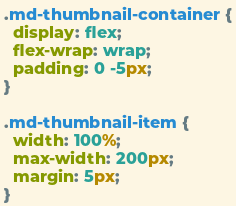<code> <loc_0><loc_0><loc_500><loc_500><_CSS_>.md-thumbnail-container {
  display: flex;
  flex-wrap: wrap;
  padding: 0 -5px;
}

.md-thumbnail-item {
  width: 100%;
  max-width: 200px;
  margin: 5px;
}</code> 